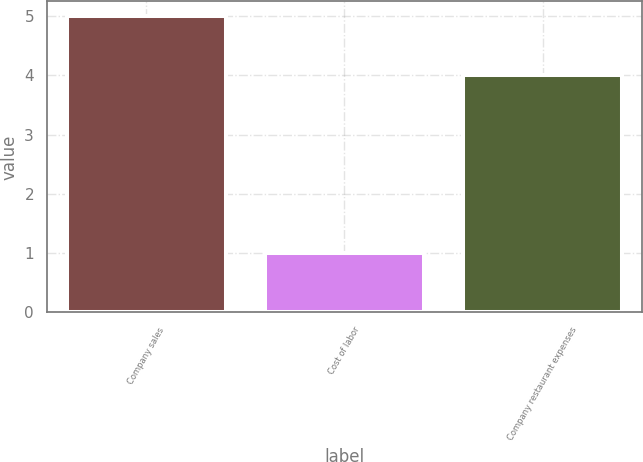Convert chart to OTSL. <chart><loc_0><loc_0><loc_500><loc_500><bar_chart><fcel>Company sales<fcel>Cost of labor<fcel>Company restaurant expenses<nl><fcel>5<fcel>1<fcel>4<nl></chart> 